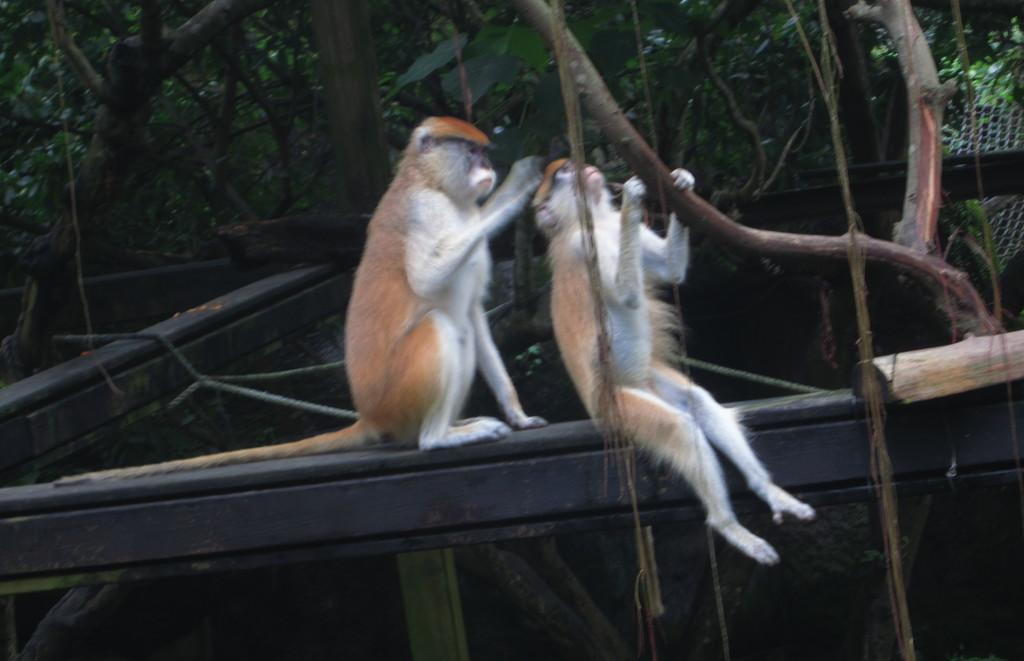What type of animals are present in the image? There are monkeys in the image. What material are the poles made of in the image? The poles in the image are made of wood. What type of barrier or enclosure is visible in the image? There is mesh in the image. What type of natural feature can be seen in the image? There are branches in the image. What color is the kite that the monkeys are holding in the image? There is no kite present in the image; the monkeys are not holding any kites. 